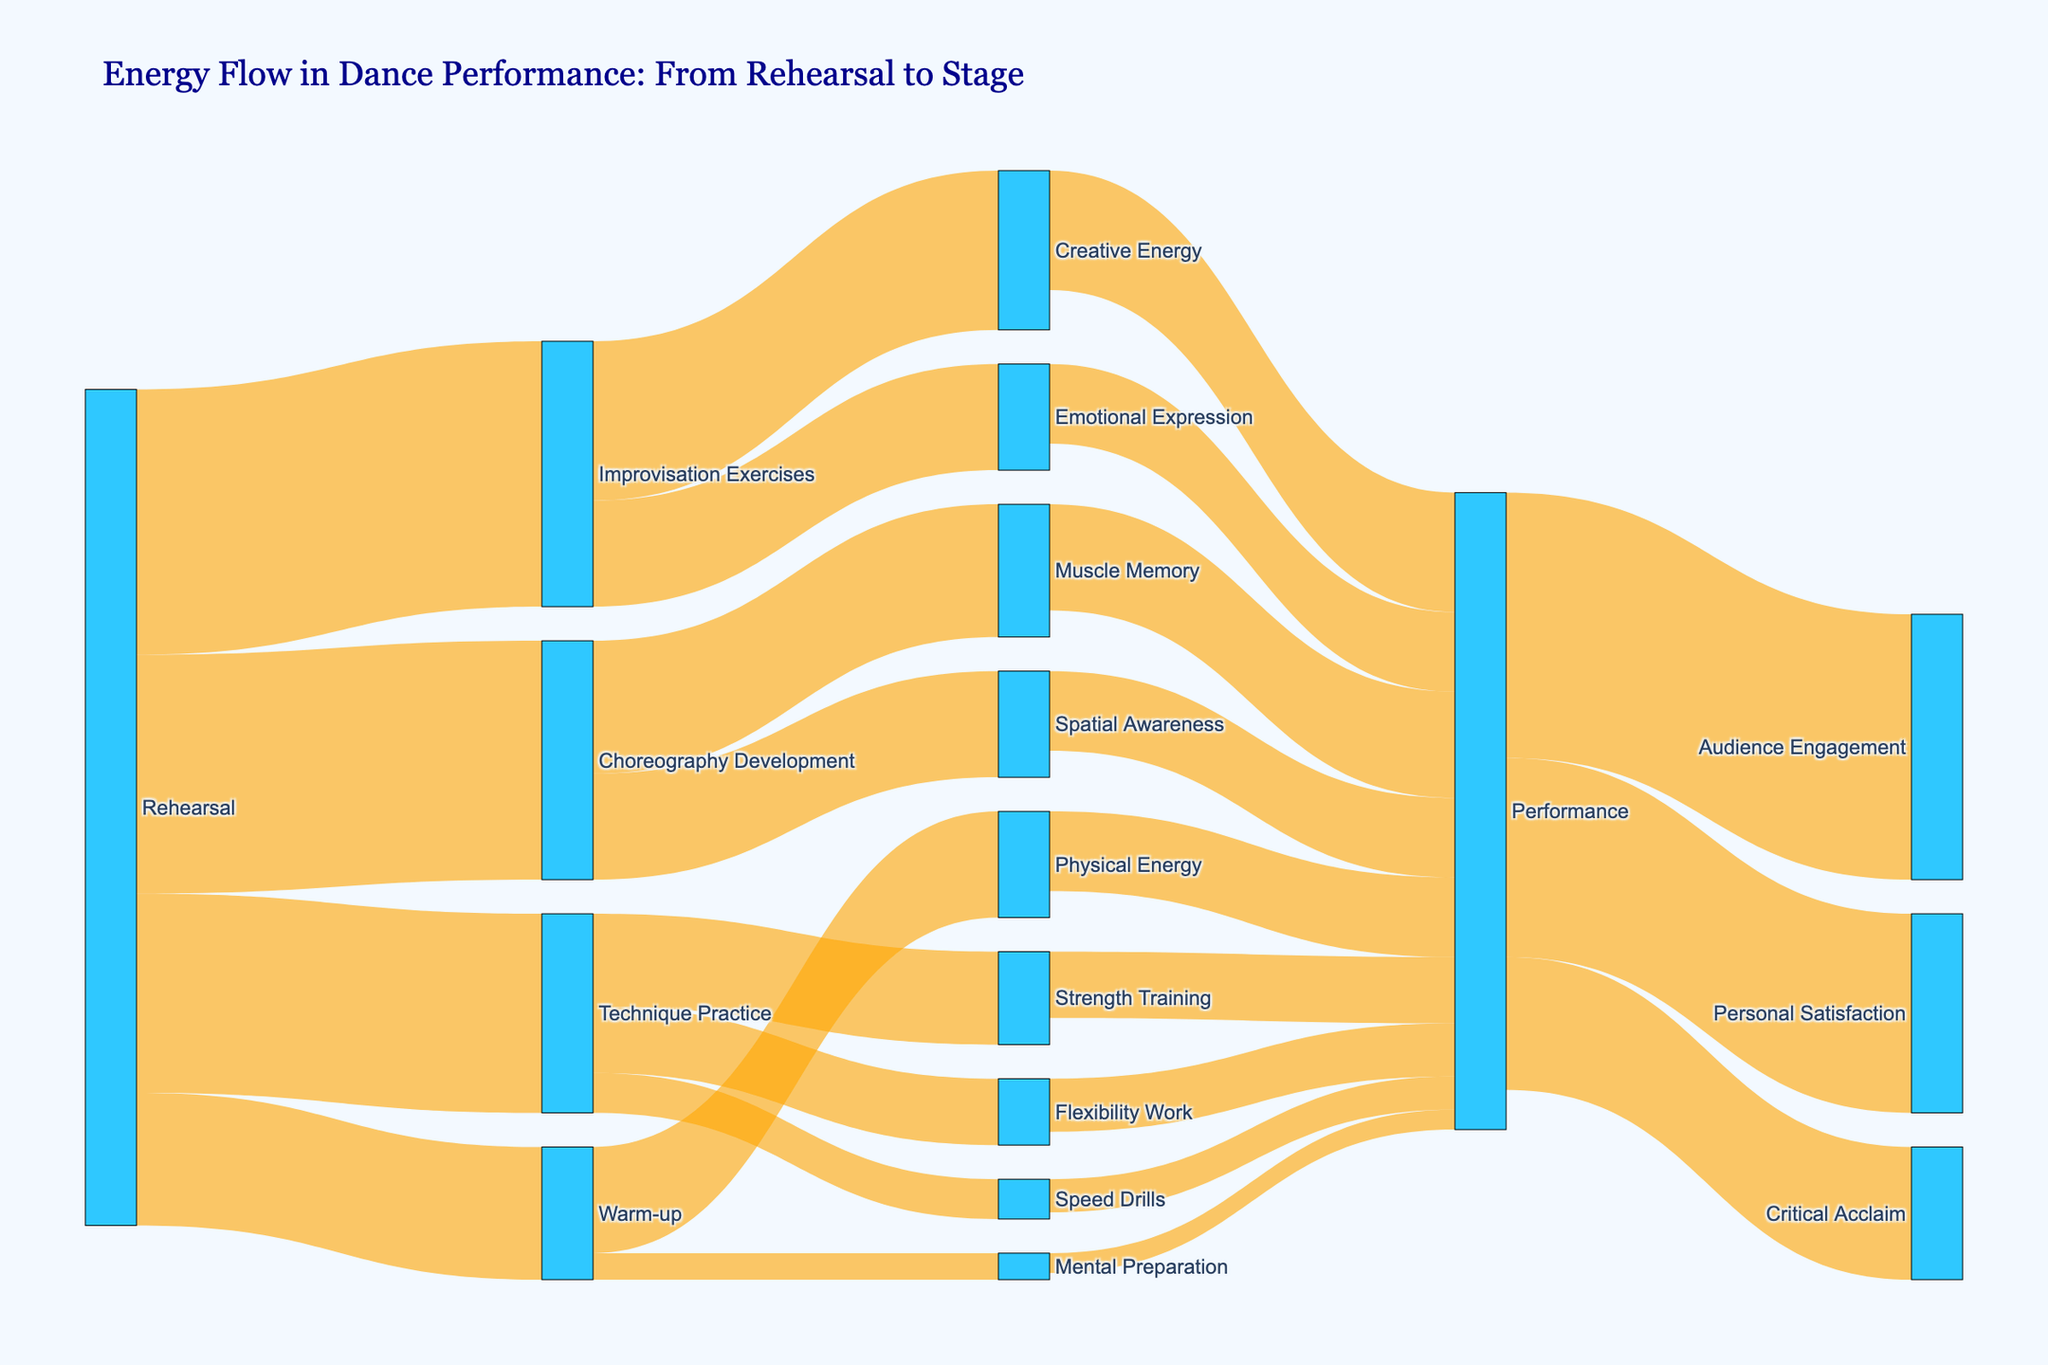What is the title of the Sankey Diagram? The title of the Sankey Diagram is usually located at the top of the figure and is used to provide a brief description of the content depicted. It helps the viewer quickly understand the main focus of the chart.
Answer: Energy Flow in Dance Performance: From Rehearsal to Stage What color represents the nodes? The color of the nodes is usually specified in the figure for visual differentiation. In this case, the nodes are colored to stand out distinctly.
Answer: Deep Sky Blue How much energy goes into 'Technique Practice' from 'Rehearsal'? To determine this, locate the link between 'Rehearsal' and 'Technique Practice' in the Sankey Diagram and read the value associated with it.
Answer: 150 How many units of 'Physical Energy' flow into 'Performance'? To answer this, find the flow from 'Physical Energy' to 'Performance' in the diagram and check the corresponding value.
Answer: 60 What is the total amount of energy flowing into 'Performance' from 'Choreography Development'? 'Choreography Development' contributes to 'Performance' through two kinds of energy: 'Muscle Memory' and 'Spatial Awareness'. Sum these values for the total contribution.
Answer: 80 + 60 = 140 Which activity from 'Rehearsal' consumes the most energy? By looking at the values of energy flows out of 'Rehearsal' to various activities, identify the highest value.
Answer: Improvisation Exercises (200) How does the energy flow from 'Performance' split between 'Audience Engagement', 'Personal Satisfaction', and 'Critical Acclaim'? To determine the split, identify and list the values flowing from 'Performance' to each of these targets.
Answer: Audience Engagement: 200, Personal Satisfaction: 150, Critical Acclaim: 100 Which form of energy contributes the most to 'Performance'? Check all types of energy leading to 'Performance' and determine the one with the highest value.
Answer: Creative Energy (90) 